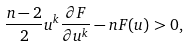Convert formula to latex. <formula><loc_0><loc_0><loc_500><loc_500>\frac { n - 2 } { 2 } u ^ { k } \frac { \partial F } { \partial u ^ { k } } - n F ( u ) > 0 ,</formula> 